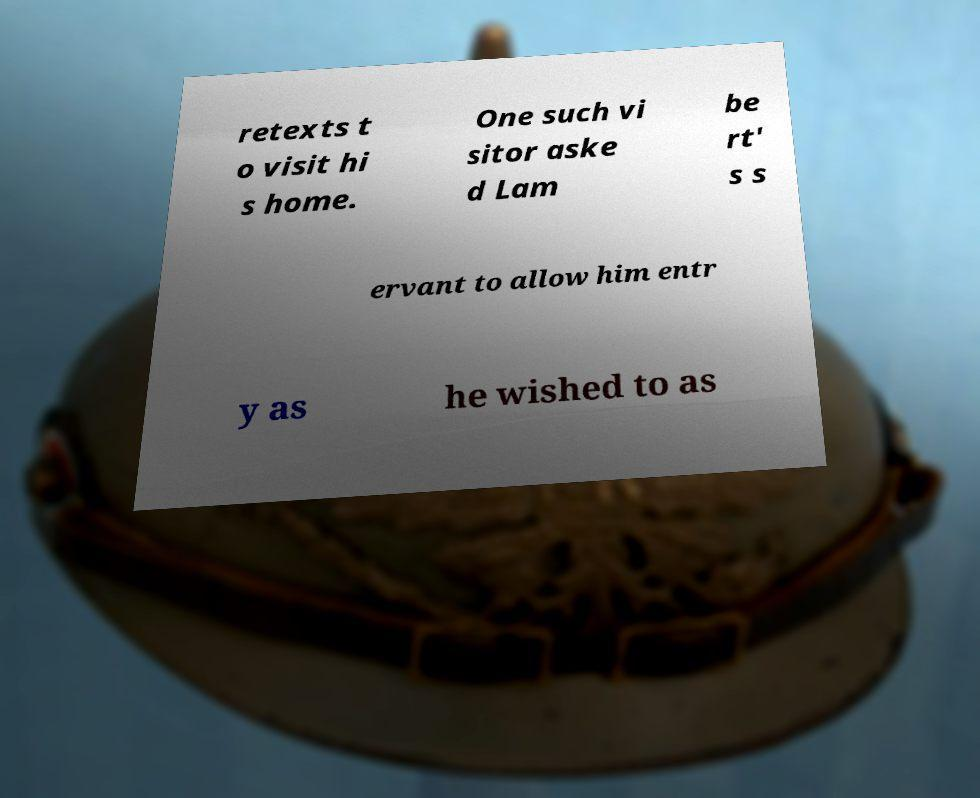For documentation purposes, I need the text within this image transcribed. Could you provide that? retexts t o visit hi s home. One such vi sitor aske d Lam be rt' s s ervant to allow him entr y as he wished to as 